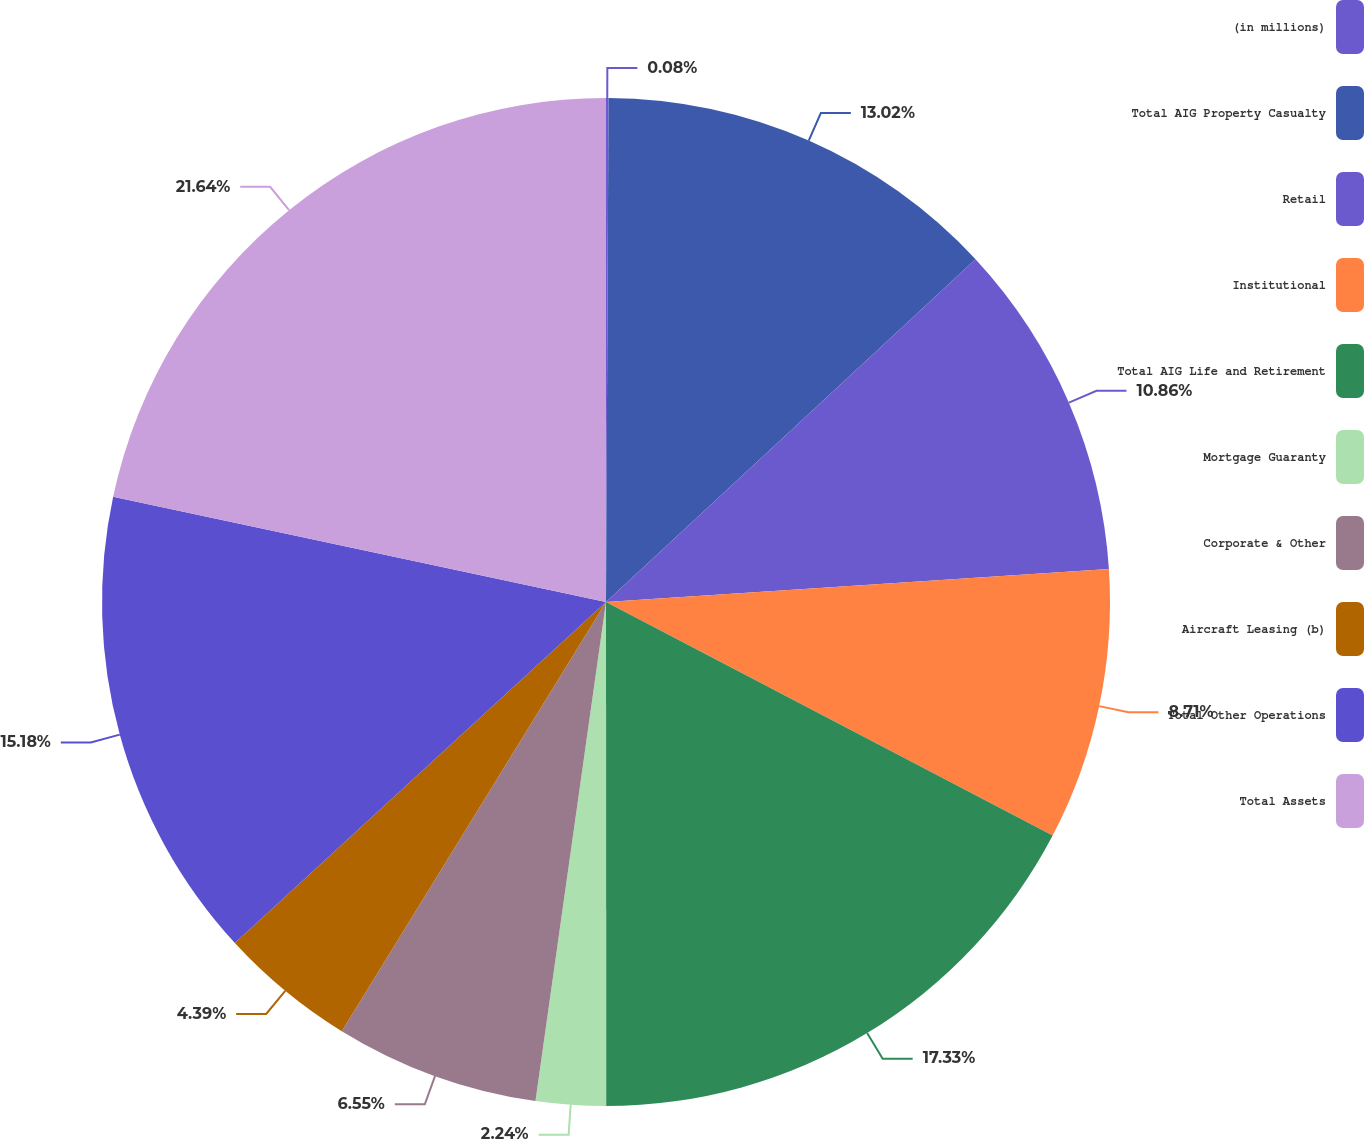Convert chart to OTSL. <chart><loc_0><loc_0><loc_500><loc_500><pie_chart><fcel>(in millions)<fcel>Total AIG Property Casualty<fcel>Retail<fcel>Institutional<fcel>Total AIG Life and Retirement<fcel>Mortgage Guaranty<fcel>Corporate & Other<fcel>Aircraft Leasing (b)<fcel>Total Other Operations<fcel>Total Assets<nl><fcel>0.08%<fcel>13.02%<fcel>10.86%<fcel>8.71%<fcel>17.33%<fcel>2.24%<fcel>6.55%<fcel>4.39%<fcel>15.18%<fcel>21.65%<nl></chart> 